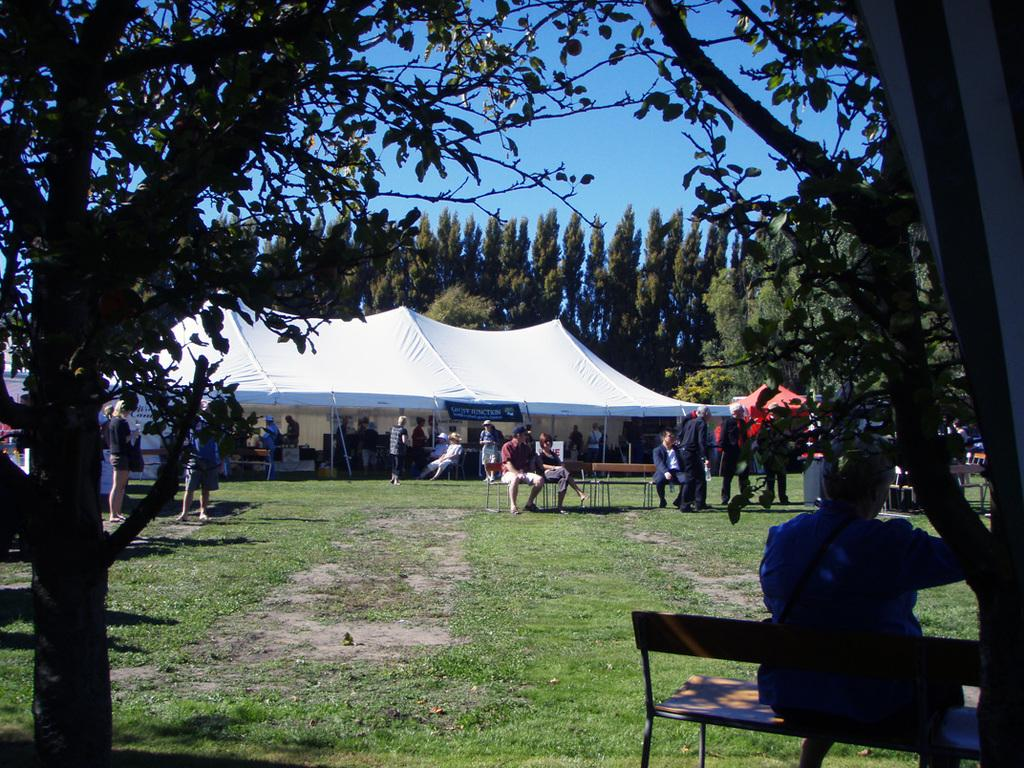What type of shelter is visible in the image? There is a tent in the image. What type of natural environment is present in the image? There are trees in the image. What is visible in the background of the image? The sky is visible in the image. What are the people in the image doing? There are people walking, sitting, and standing in the image. What type of paste is being used by the people in the image? There is no paste present in the image; the people are walking, sitting, and standing in a natural environment. 